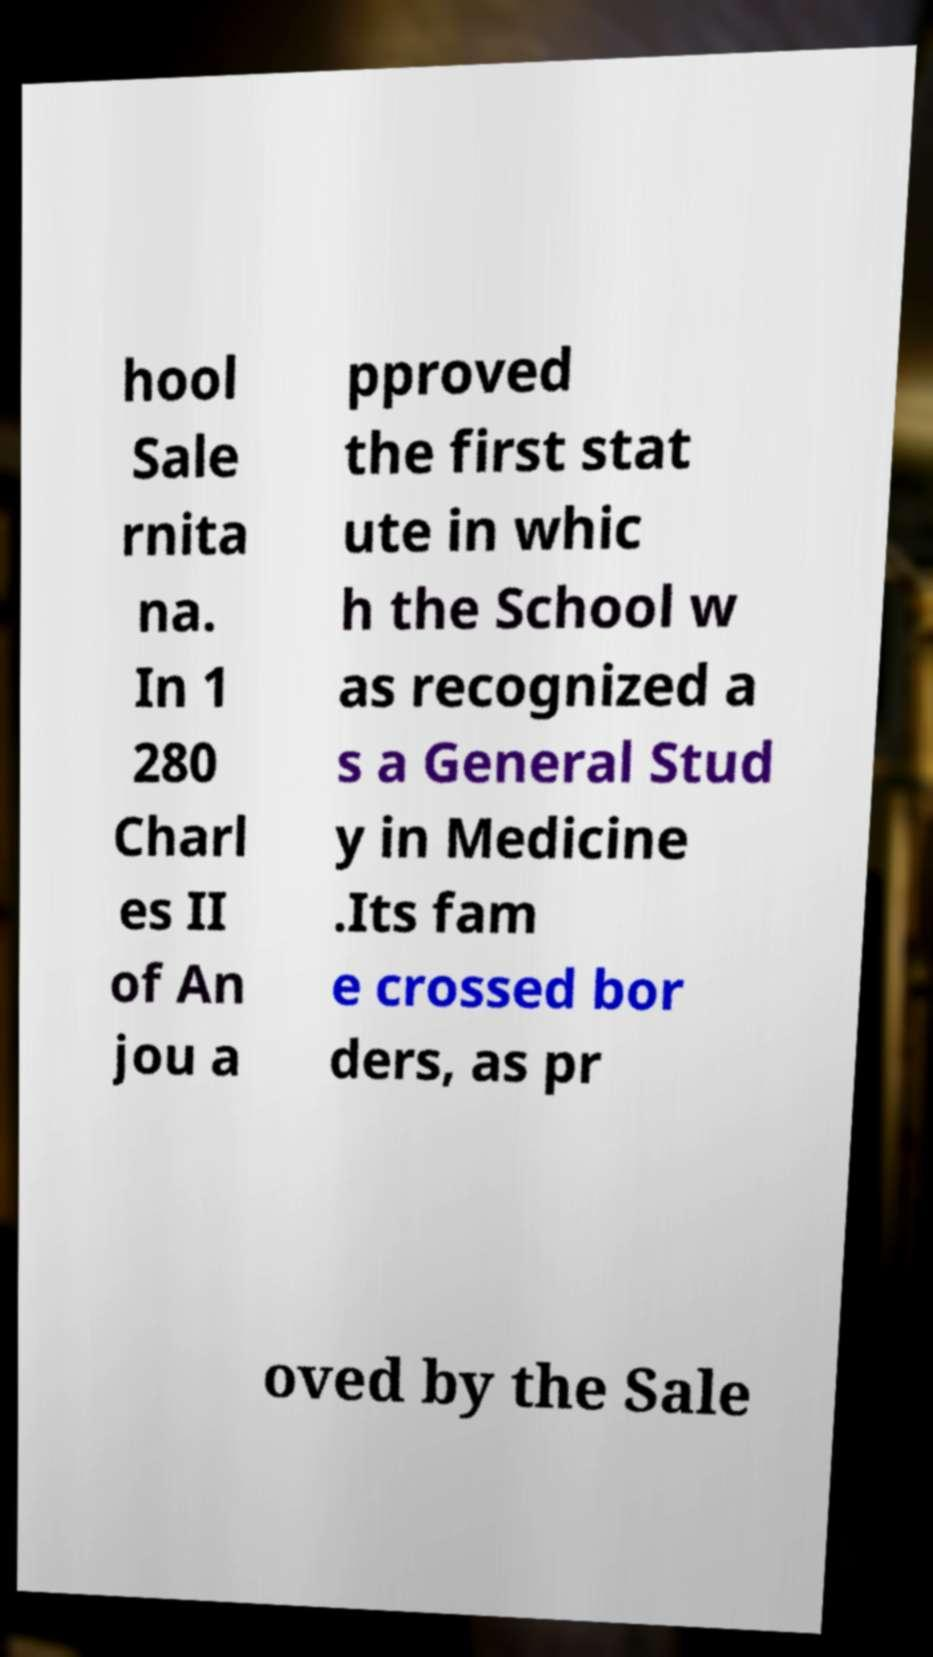I need the written content from this picture converted into text. Can you do that? hool Sale rnita na. In 1 280 Charl es II of An jou a pproved the first stat ute in whic h the School w as recognized a s a General Stud y in Medicine .Its fam e crossed bor ders, as pr oved by the Sale 